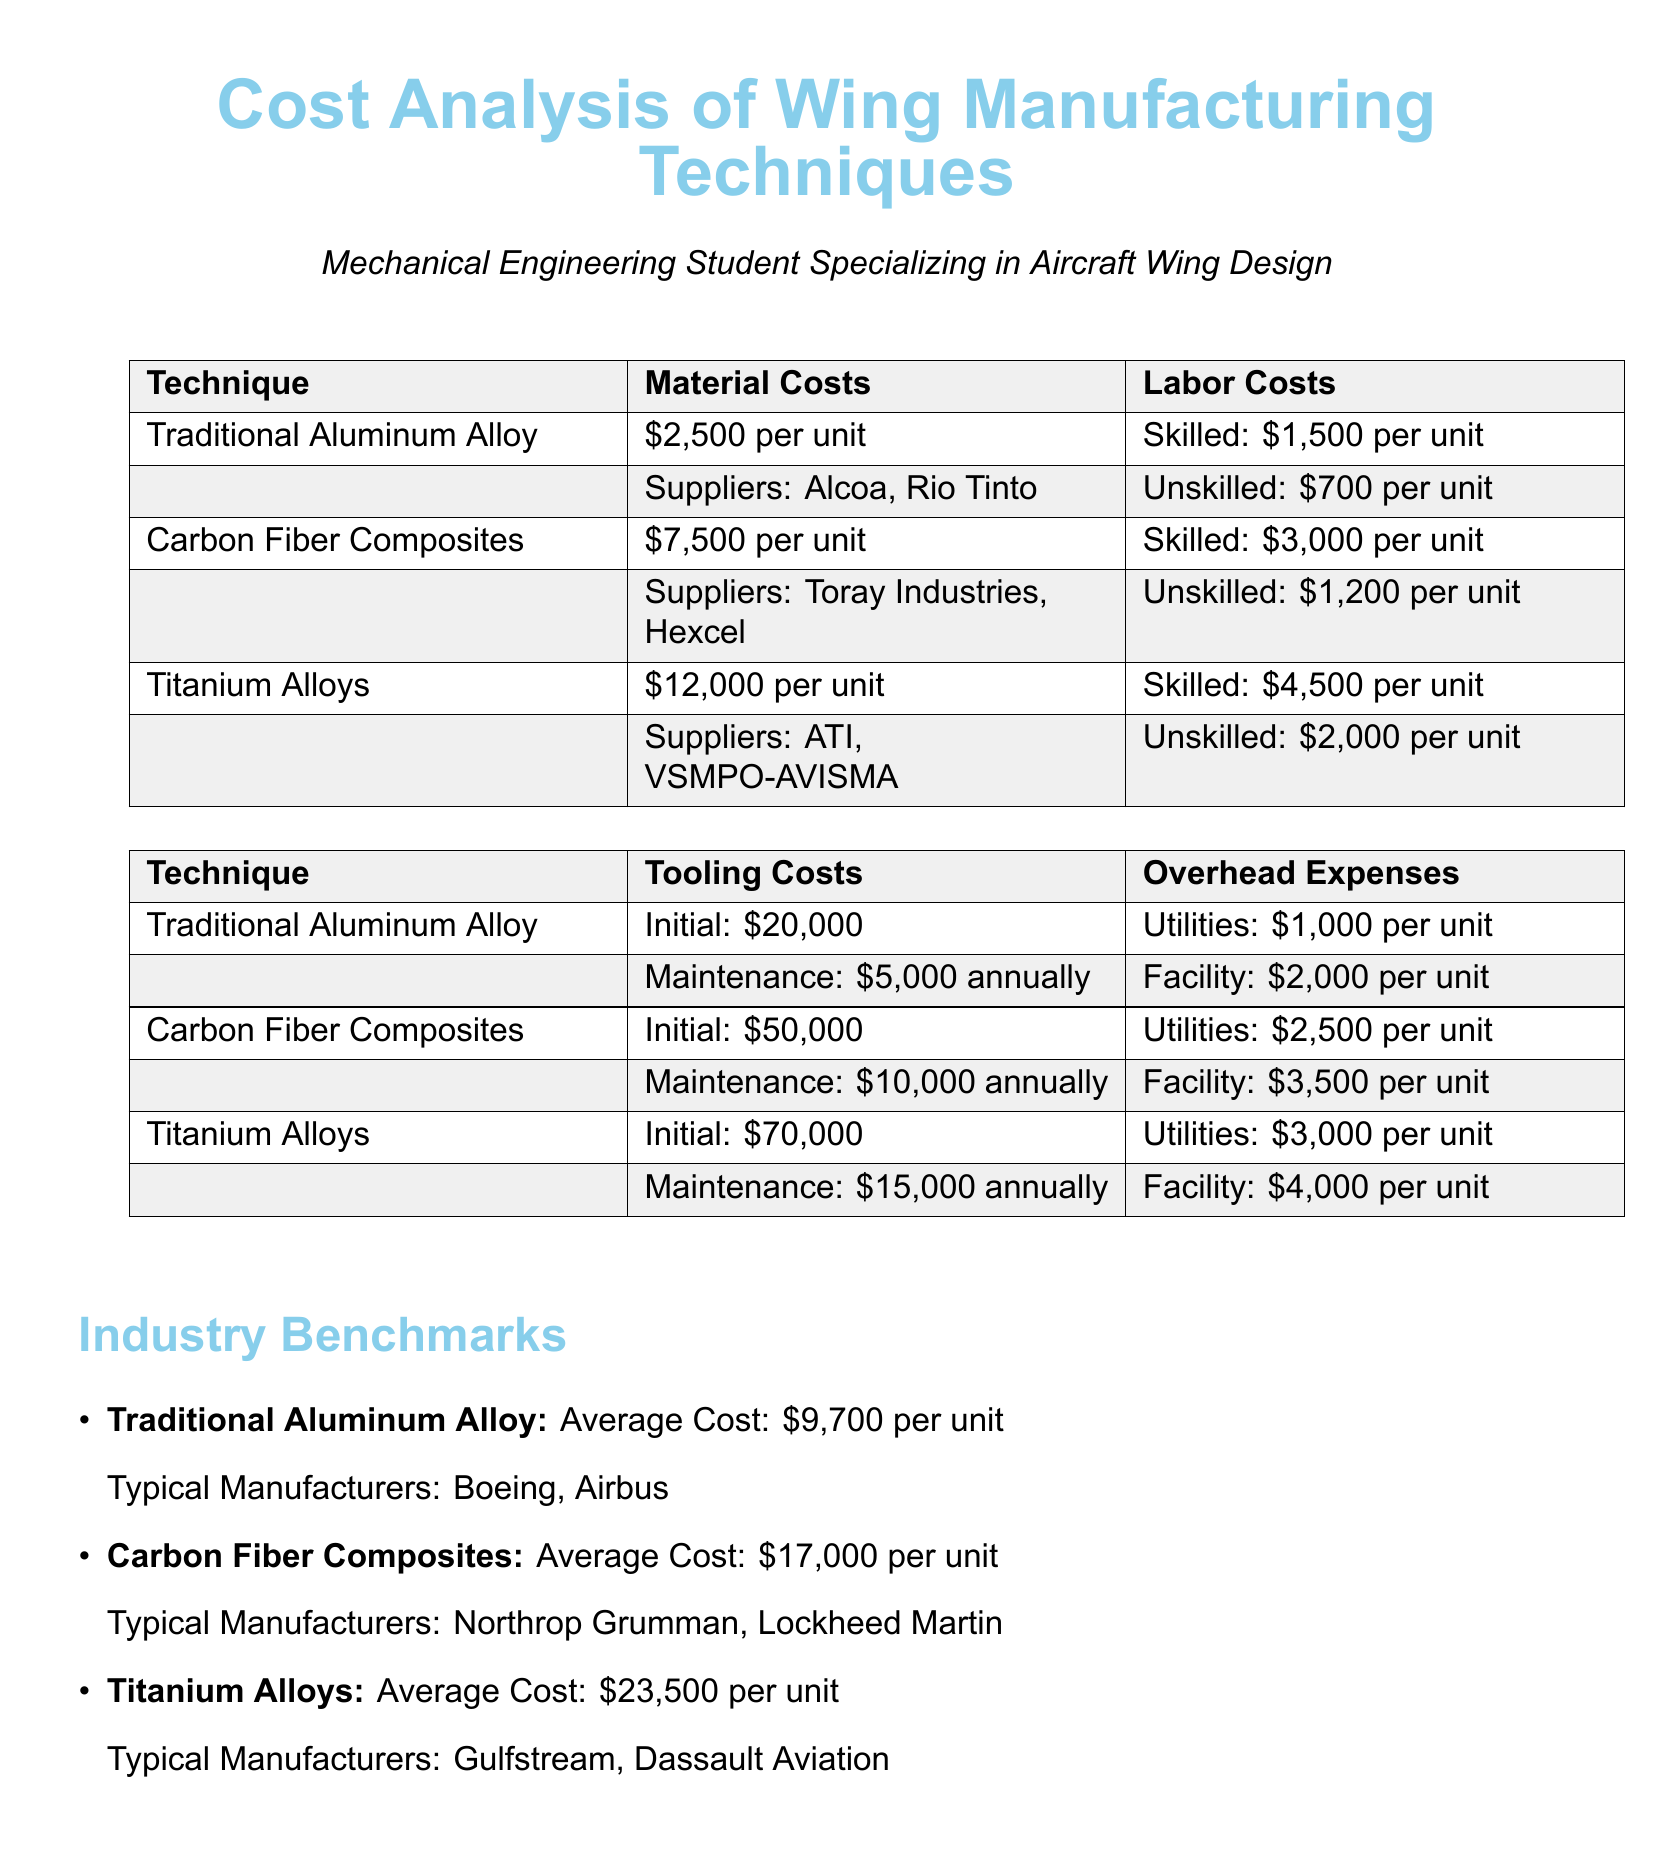What are the skilled labor costs for Carbon Fiber Composites? The skilled labor costs for Carbon Fiber Composites are listed in the document as $3,000 per unit.
Answer: $3,000 per unit What is the initial tooling cost for Titanium Alloys? The initial tooling cost for Titanium Alloys is provided in the document as $70,000.
Answer: $70,000 Which suppliers are associated with Traditional Aluminum Alloy? The suppliers associated with Traditional Aluminum Alloy are Alcoa and Rio Tinto, as mentioned in the document.
Answer: Alcoa, Rio Tinto What is the overhead expense for utilities in Carbon Fiber Composites? The document specifies the overhead expense for utilities in Carbon Fiber Composites as $2,500 per unit.
Answer: $2,500 per unit How do the average costs of Titanium Alloys compare to industry benchmarks? The average cost of Titanium Alloys is $23,500, which can be compared to the provided industry benchmark in the document.
Answer: $23,500 What is the labor cost for unskilled labor in Traditional Aluminum Alloy? The unskilled labor cost for Traditional Aluminum Alloy is detailed as $700 per unit in the document.
Answer: $700 per unit What maintenance cost is associated with tooling for Carbon Fiber Composites? The maintenance cost associated with tooling for Carbon Fiber Composites is stated as $10,000 annually in the document.
Answer: $10,000 annually What is the overhead expense for facilities in Titanium Alloys? The overhead expense for facilities in Titanium Alloys is listed in the document as $4,000 per unit.
Answer: $4,000 per unit Which manufacturers typically produce Carbon Fiber Composites? The document mentions Northrop Grumman and Lockheed Martin as typical manufacturers of Carbon Fiber Composites.
Answer: Northrop Grumman, Lockheed Martin 